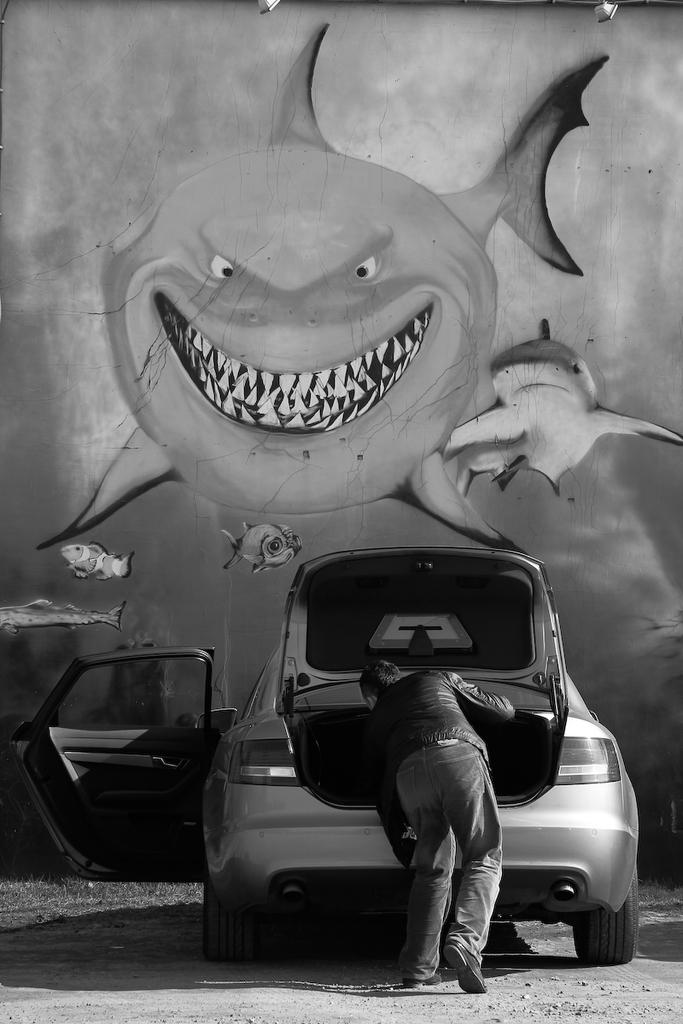What is happening in the foreground of the image? There is a person standing in front of a vehicle. What is the color scheme of the image? The image is black and white. What can be seen in the background of the image? There is a wall painting in the background. How many flocks of birds are flying over the sea in the image? There is no sea or birds present in the image; it features a person standing in front of a vehicle with a black and white color scheme and a wall painting in the background. 